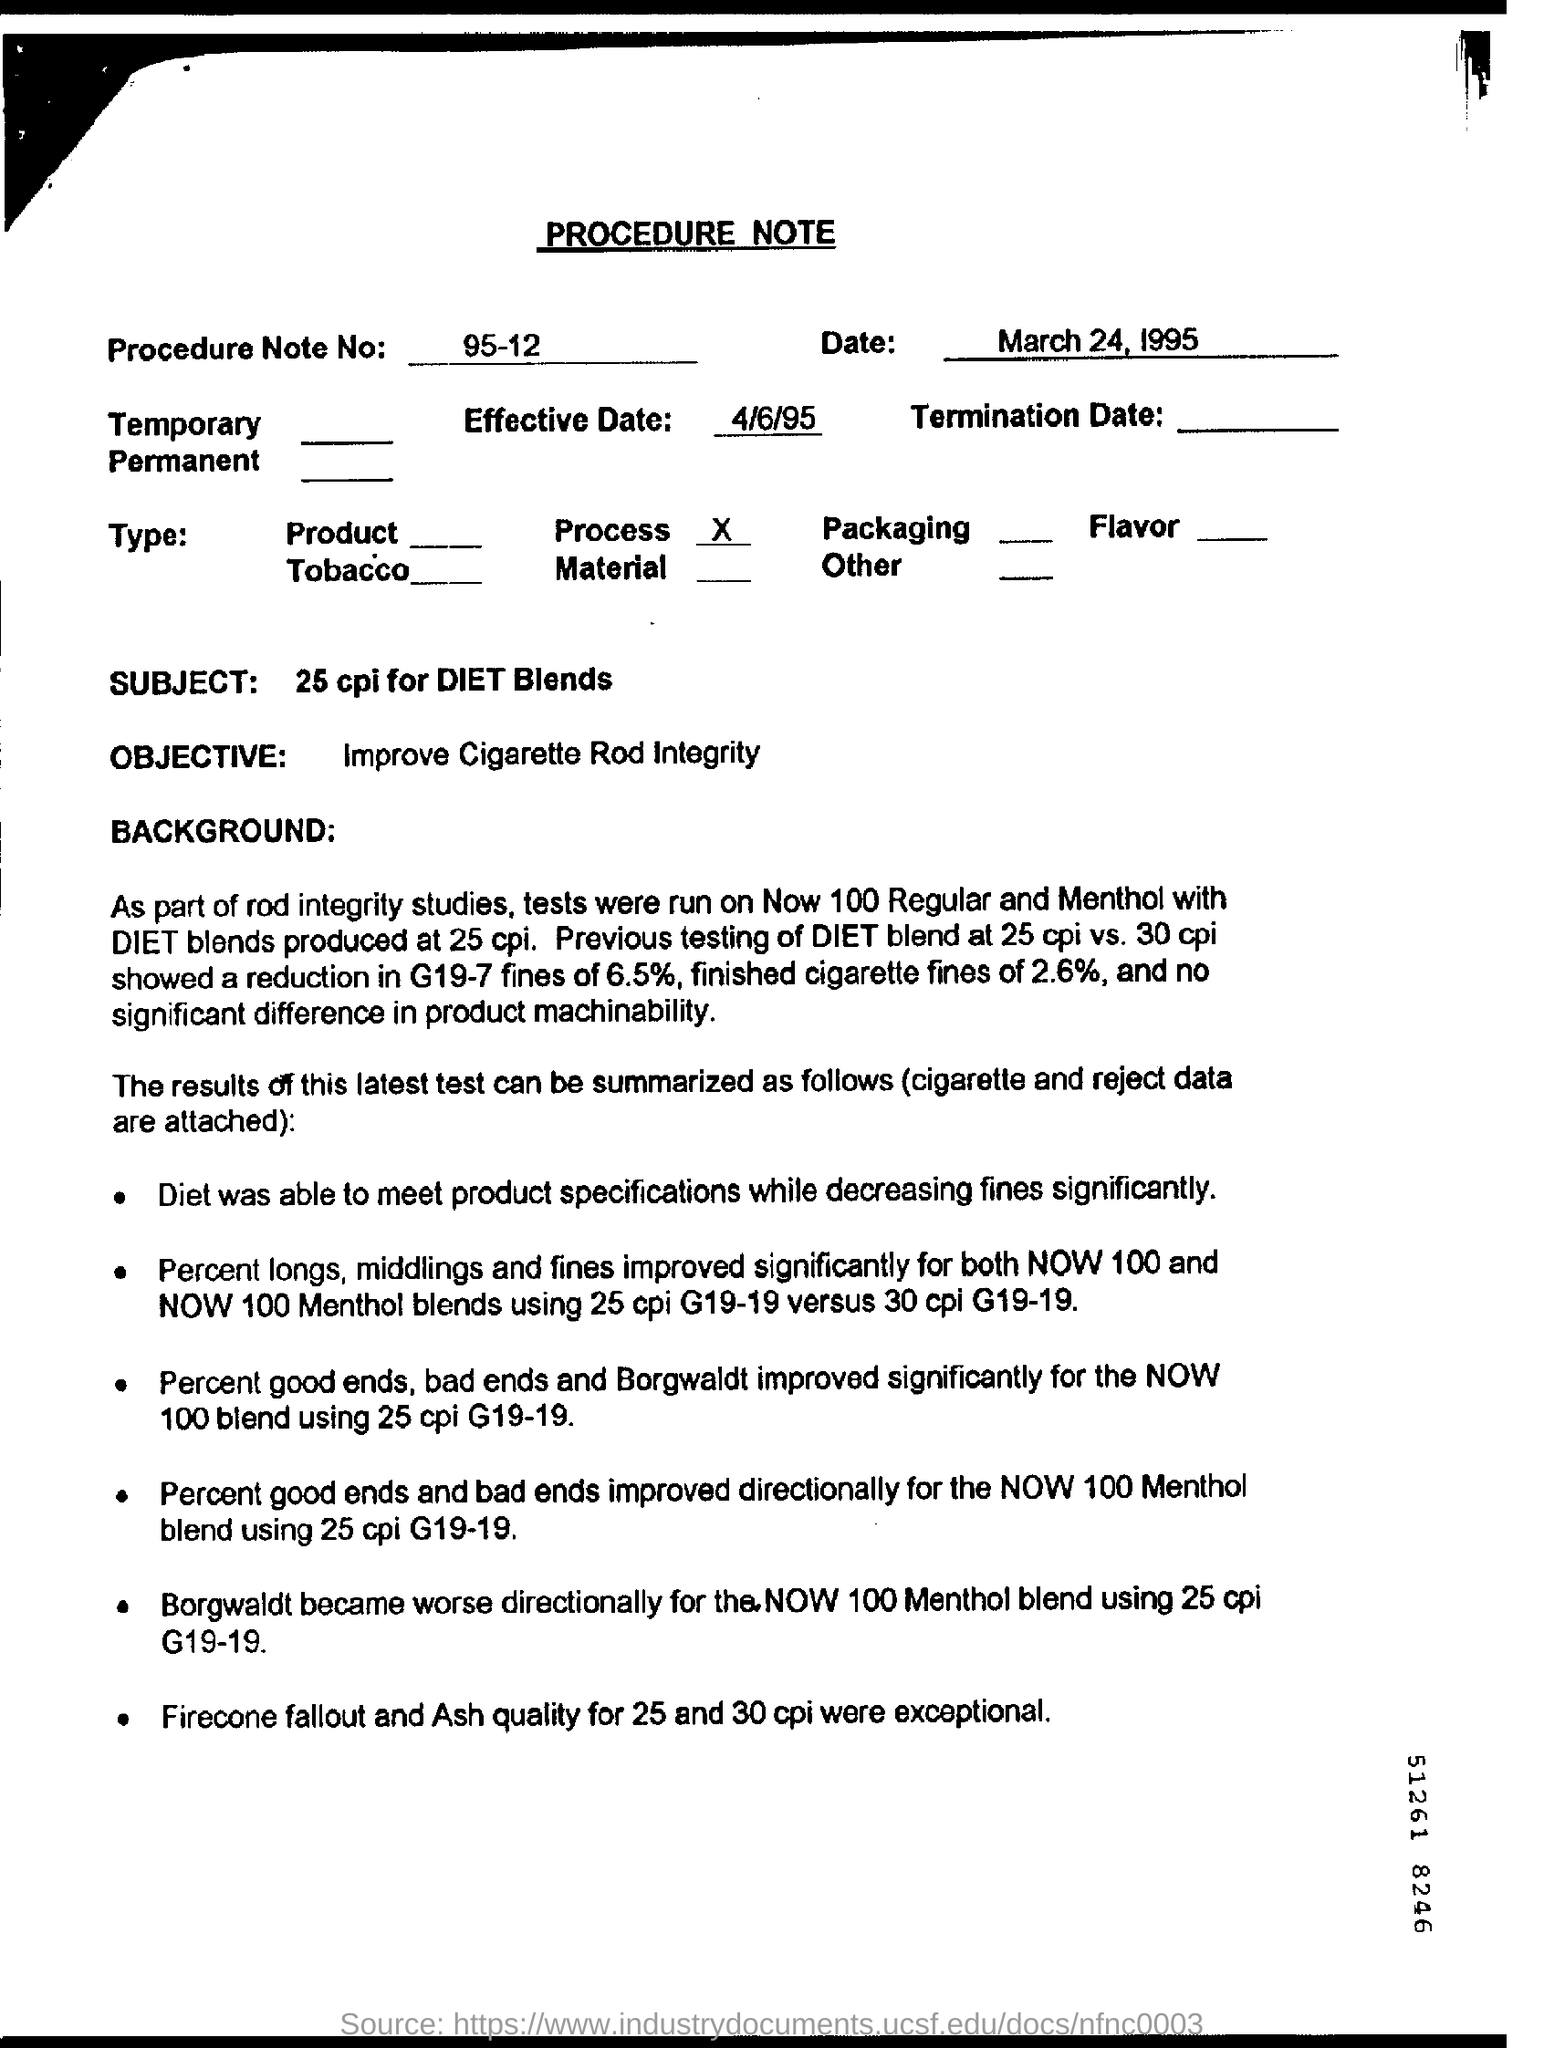What is the Procedure Note No?
Give a very brief answer. 95-12. What is the Subject of the procedure note?
Your response must be concise. 25 cpi for DIET Blends. What is the effective date mentioned in the form?
Ensure brevity in your answer.  4/6/95. 